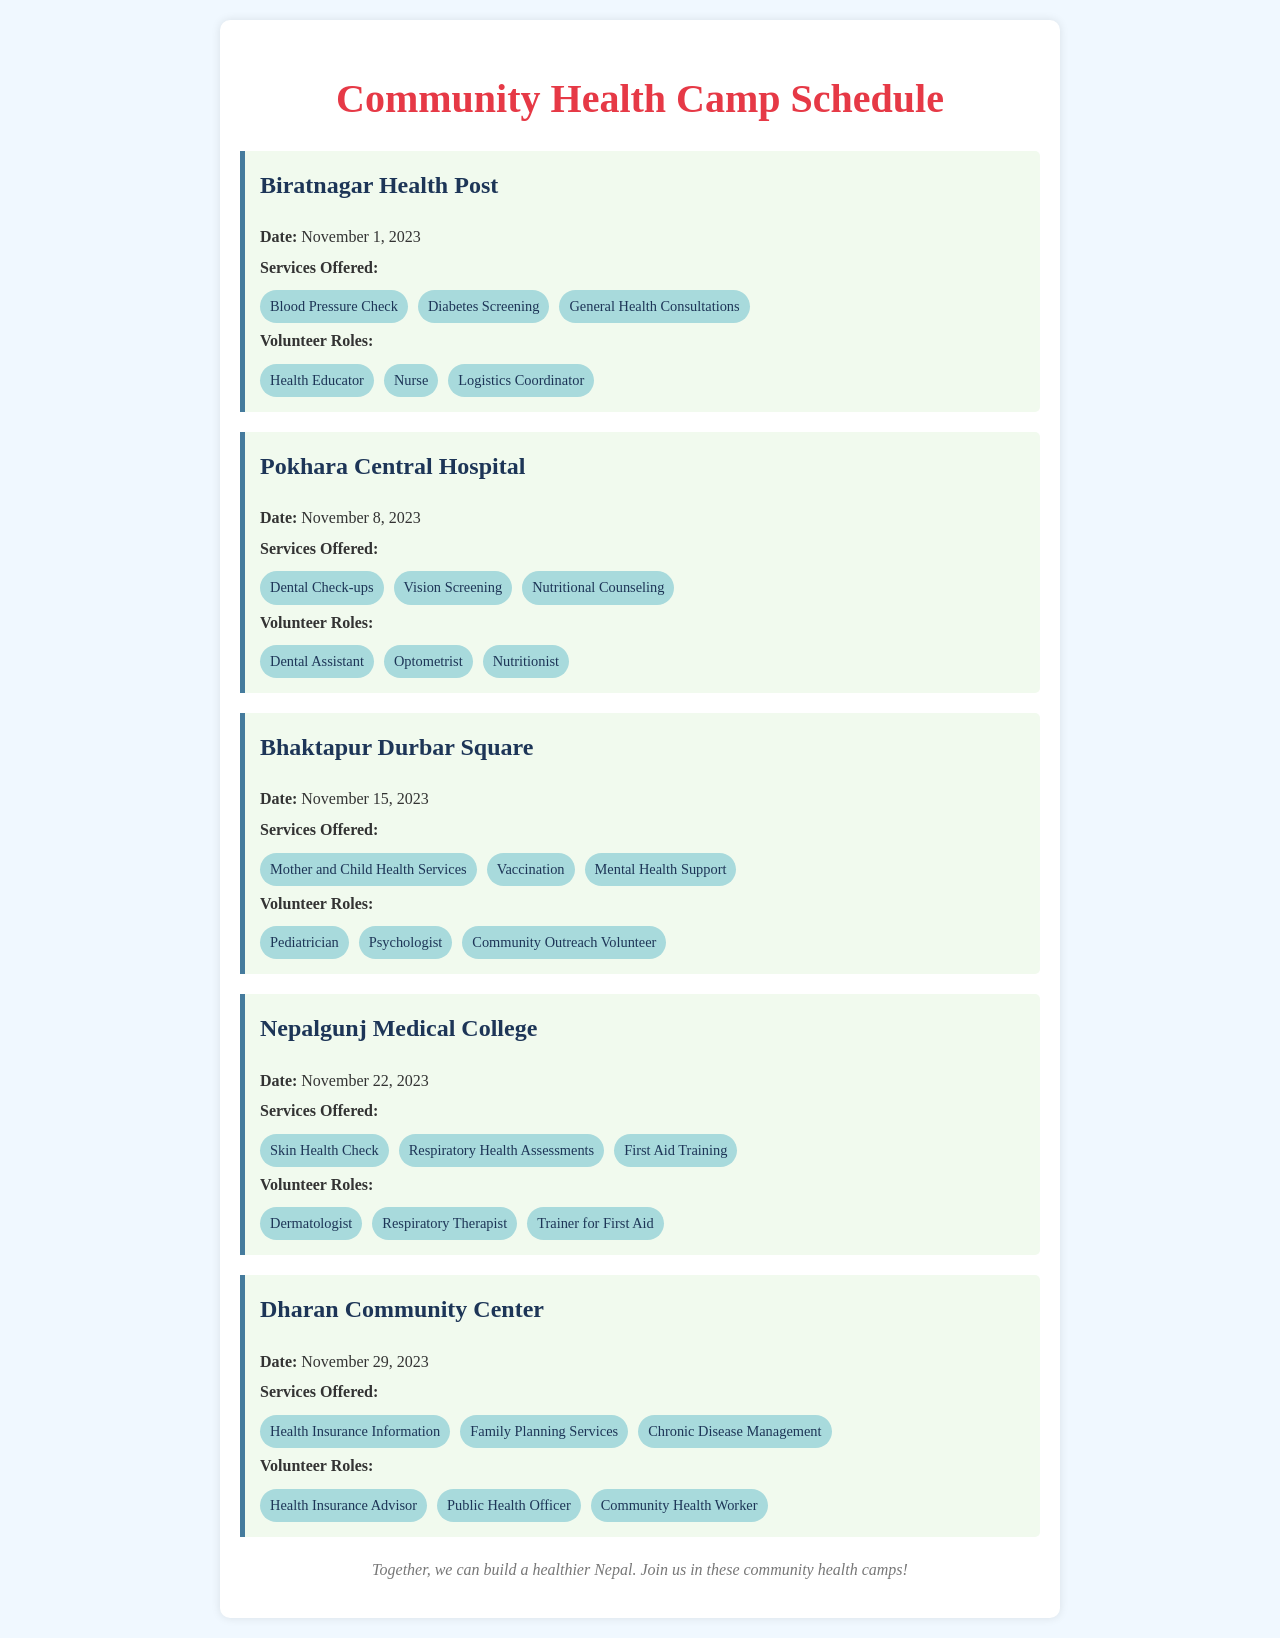what is the date of the health camp at Biratnagar Health Post? The date of the health camp at Biratnagar Health Post is explicitly stated in the document.
Answer: November 1, 2023 what services are offered at Pokhara Central Hospital? The services offered are listed in the document under the Pokhara Central Hospital section.
Answer: Dental Check-ups, Vision Screening, Nutritional Counseling who is the volunteer role listed for mental health support at Bhaktapur Durbar Square? The volunteer roles are listed under the Bhaktapur Durbar Square event, indicating who is responsible for mental health support.
Answer: Psychologist how many health camps are scheduled before November 29, 2023? The schedule includes several camps with specific dates, allowing us to count them before November 29, 2023.
Answer: 4 which service is not offered at Nepalgunj Medical College? The document lists the services offered at Nepalgunj Medical College, allowing us to identify any specific service that is absent.
Answer: Vaccination which role does not appear in the list for Dharan Community Center? By comparing the roles offered in the document, we can determine which role is missing from the Dharan Community Center listing.
Answer: Dermatologist what type of event is described in this document? The content of the document describes specific health-related events aimed at the community, making the event type clear.
Answer: Community Health Camp what is the location for the health camp on November 15, 2023? The event detailing the date will reveal the corresponding location listed in the cab document.
Answer: Bhaktapur Durbar Square 